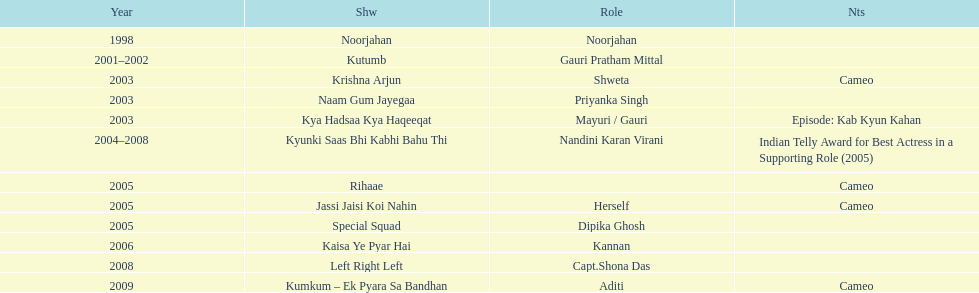What was the first tv series that gauri tejwani appeared in? Noorjahan. 